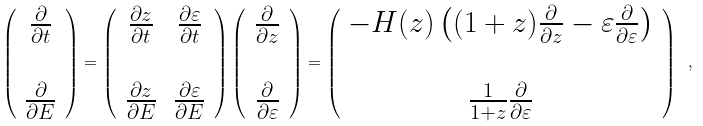<formula> <loc_0><loc_0><loc_500><loc_500>\left ( \begin{array} { c } \frac { \partial } { \partial t } \\ \\ \frac { \partial } { \partial E } \end{array} \right ) = \left ( \begin{array} { c c } \frac { \partial z } { \partial t } & \frac { \partial \varepsilon } { \partial t } \\ \\ \frac { \partial z } { \partial E } & \frac { \partial \varepsilon } { \partial E } \\ \end{array} \right ) \left ( \begin{array} { c } \frac { \partial } { \partial z } \\ \\ \frac { \partial } { \partial \varepsilon } \end{array} \right ) = \left ( \begin{array} { c } - H ( z ) \left ( ( 1 + z ) \frac { \partial } { \partial z } - \varepsilon \frac { \partial } { \partial \varepsilon } \right ) \\ \\ \frac { 1 } { 1 + z } \frac { \partial } { \partial \varepsilon } \end{array} \right ) \ ,</formula> 